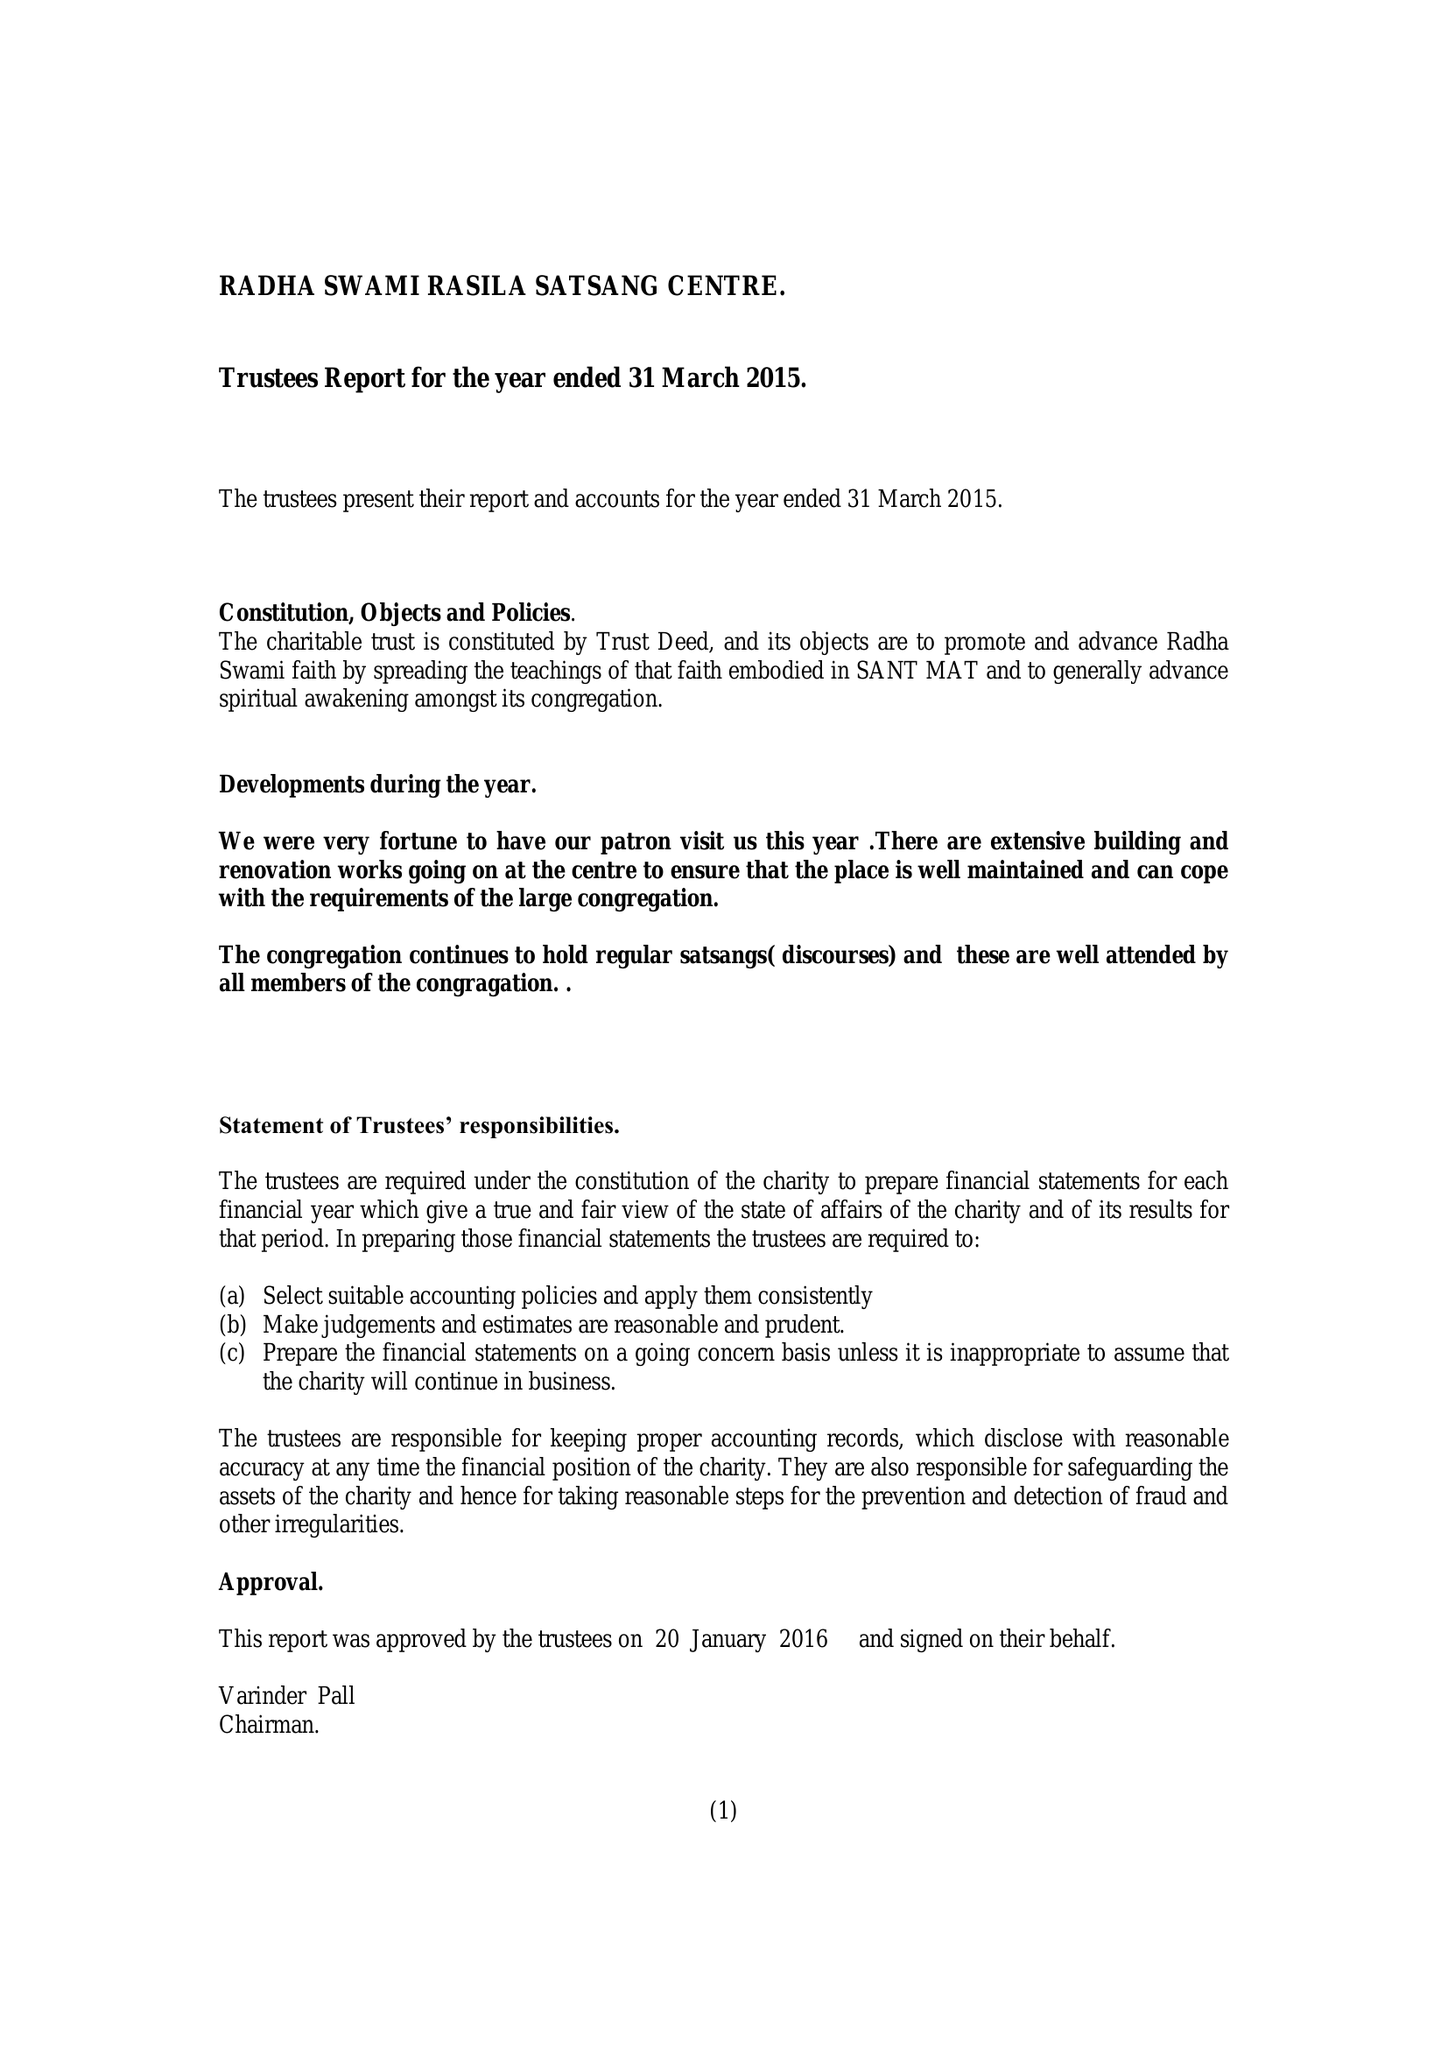What is the value for the address__street_line?
Answer the question using a single word or phrase. WHARF STREET 